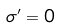Convert formula to latex. <formula><loc_0><loc_0><loc_500><loc_500>\sigma ^ { \prime } = 0</formula> 